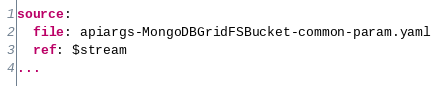Convert code to text. <code><loc_0><loc_0><loc_500><loc_500><_YAML_>source:
  file: apiargs-MongoDBGridFSBucket-common-param.yaml
  ref: $stream
...
</code> 